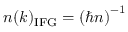<formula> <loc_0><loc_0><loc_500><loc_500>n ( k ) _ { I F G } = \left ( \hbar { n } \right ) ^ { - 1 }</formula> 